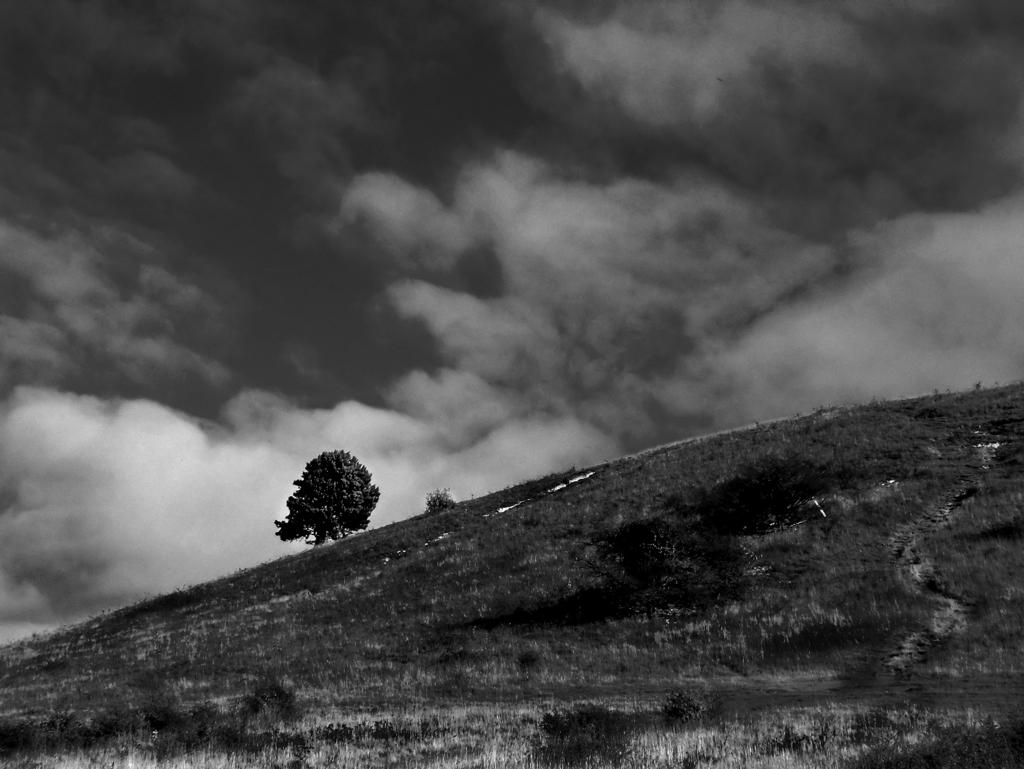What is the color scheme of the image? The image is black and white. What type of vegetation can be seen in the image? There is grass in the image. What other natural element is present in the image? There is a tree in the image. What is visible in the sky at the top of the image? There are clouds in the sky at the top of the image. How many icicles are hanging from the tree in the image? There are no icicles present in the image, as it is a black and white image with grass, a tree, and clouds in the sky. What level of expertise does the beginner have in the image? There is no indication of any person or skill level in the image, as it primarily features natural elements like grass, a tree, and clouds. 